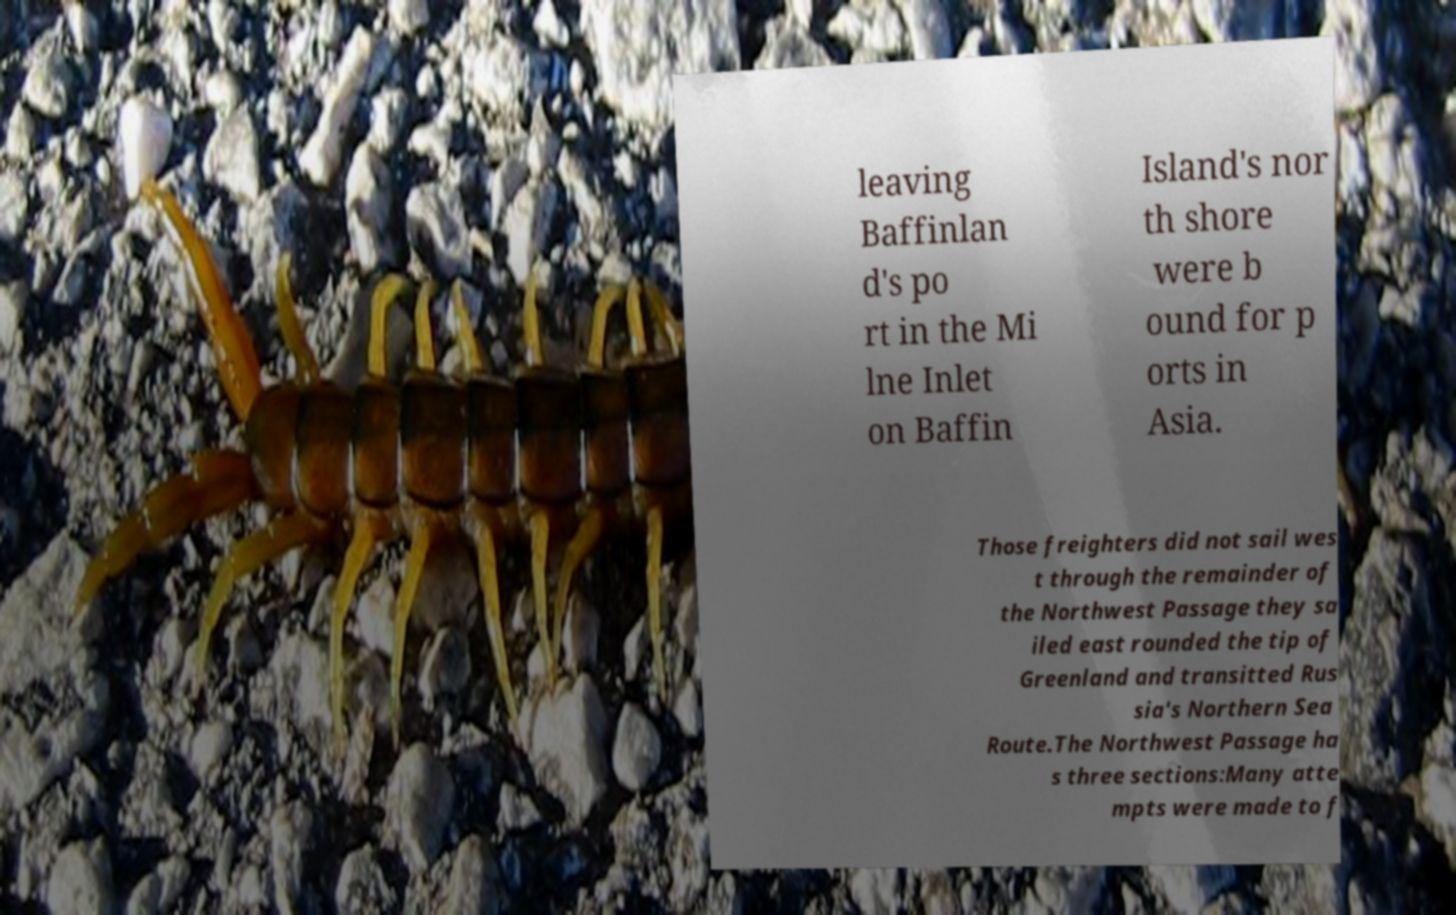Can you accurately transcribe the text from the provided image for me? leaving Baffinlan d's po rt in the Mi lne Inlet on Baffin Island's nor th shore were b ound for p orts in Asia. Those freighters did not sail wes t through the remainder of the Northwest Passage they sa iled east rounded the tip of Greenland and transitted Rus sia's Northern Sea Route.The Northwest Passage ha s three sections:Many atte mpts were made to f 